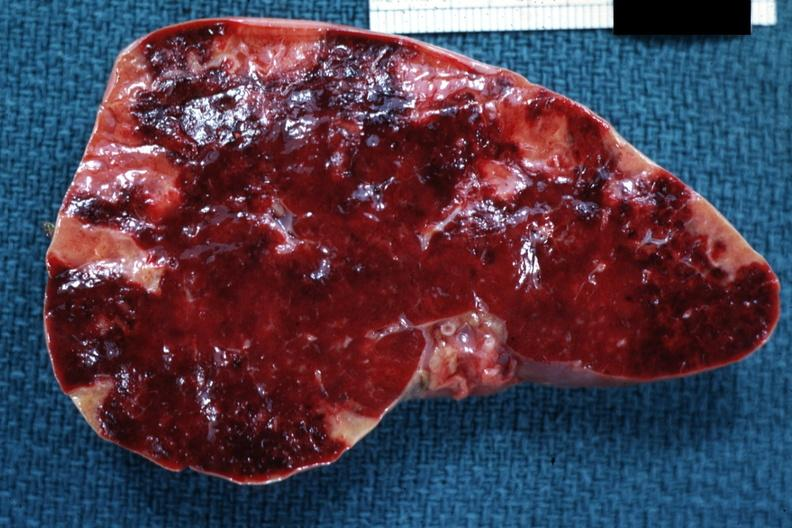what does this image show?
Answer the question using a single word or phrase. Cut surface of spleen with multiple recent infarcts very good example 